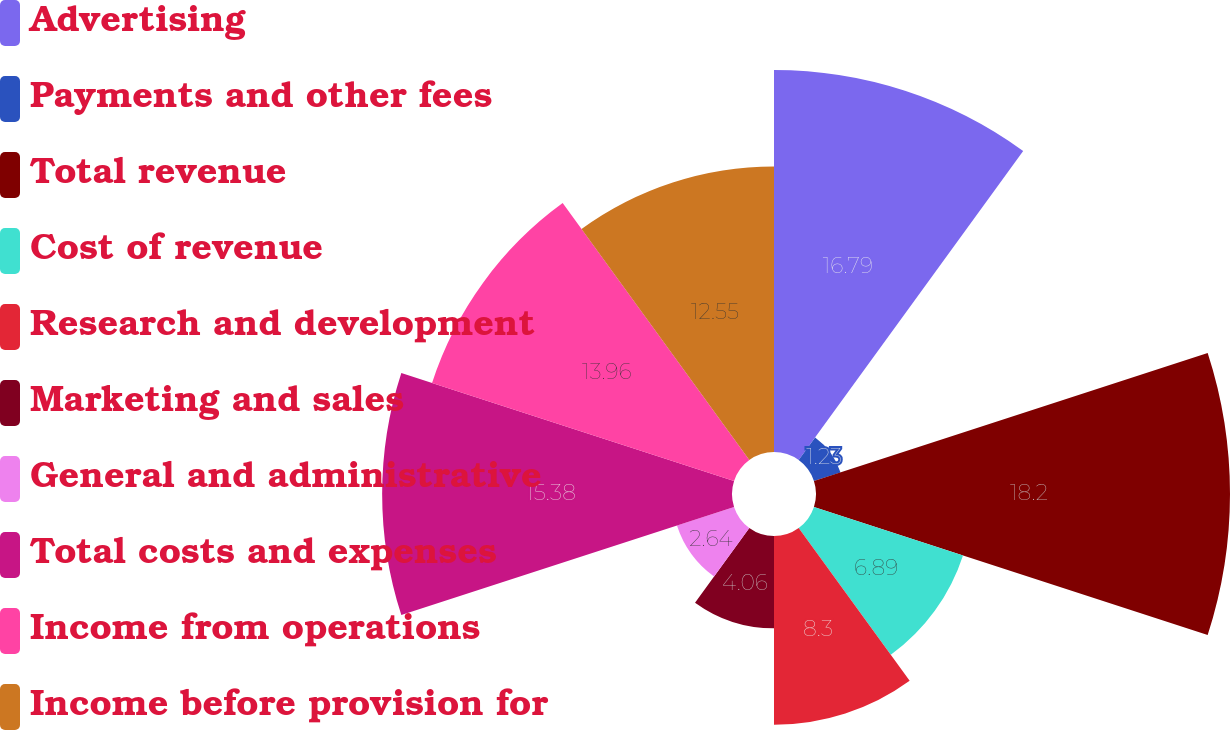Convert chart. <chart><loc_0><loc_0><loc_500><loc_500><pie_chart><fcel>Advertising<fcel>Payments and other fees<fcel>Total revenue<fcel>Cost of revenue<fcel>Research and development<fcel>Marketing and sales<fcel>General and administrative<fcel>Total costs and expenses<fcel>Income from operations<fcel>Income before provision for<nl><fcel>16.79%<fcel>1.23%<fcel>18.2%<fcel>6.89%<fcel>8.3%<fcel>4.06%<fcel>2.64%<fcel>15.38%<fcel>13.96%<fcel>12.55%<nl></chart> 